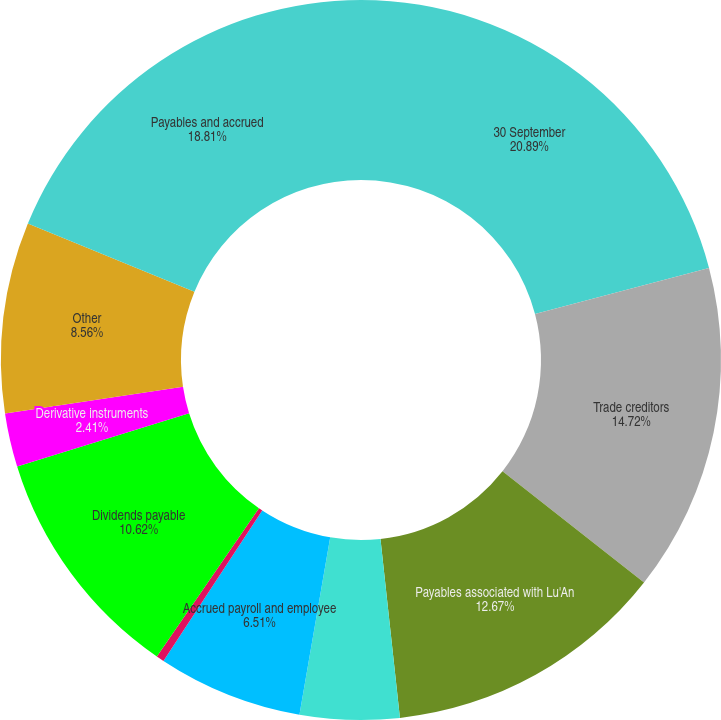<chart> <loc_0><loc_0><loc_500><loc_500><pie_chart><fcel>30 September<fcel>Trade creditors<fcel>Payables associated with Lu'An<fcel>Contract liabilities<fcel>Accrued payroll and employee<fcel>Pension and postretirement<fcel>Dividends payable<fcel>Derivative instruments<fcel>Other<fcel>Payables and accrued<nl><fcel>20.88%<fcel>14.72%<fcel>12.67%<fcel>4.46%<fcel>6.51%<fcel>0.35%<fcel>10.62%<fcel>2.41%<fcel>8.56%<fcel>18.81%<nl></chart> 